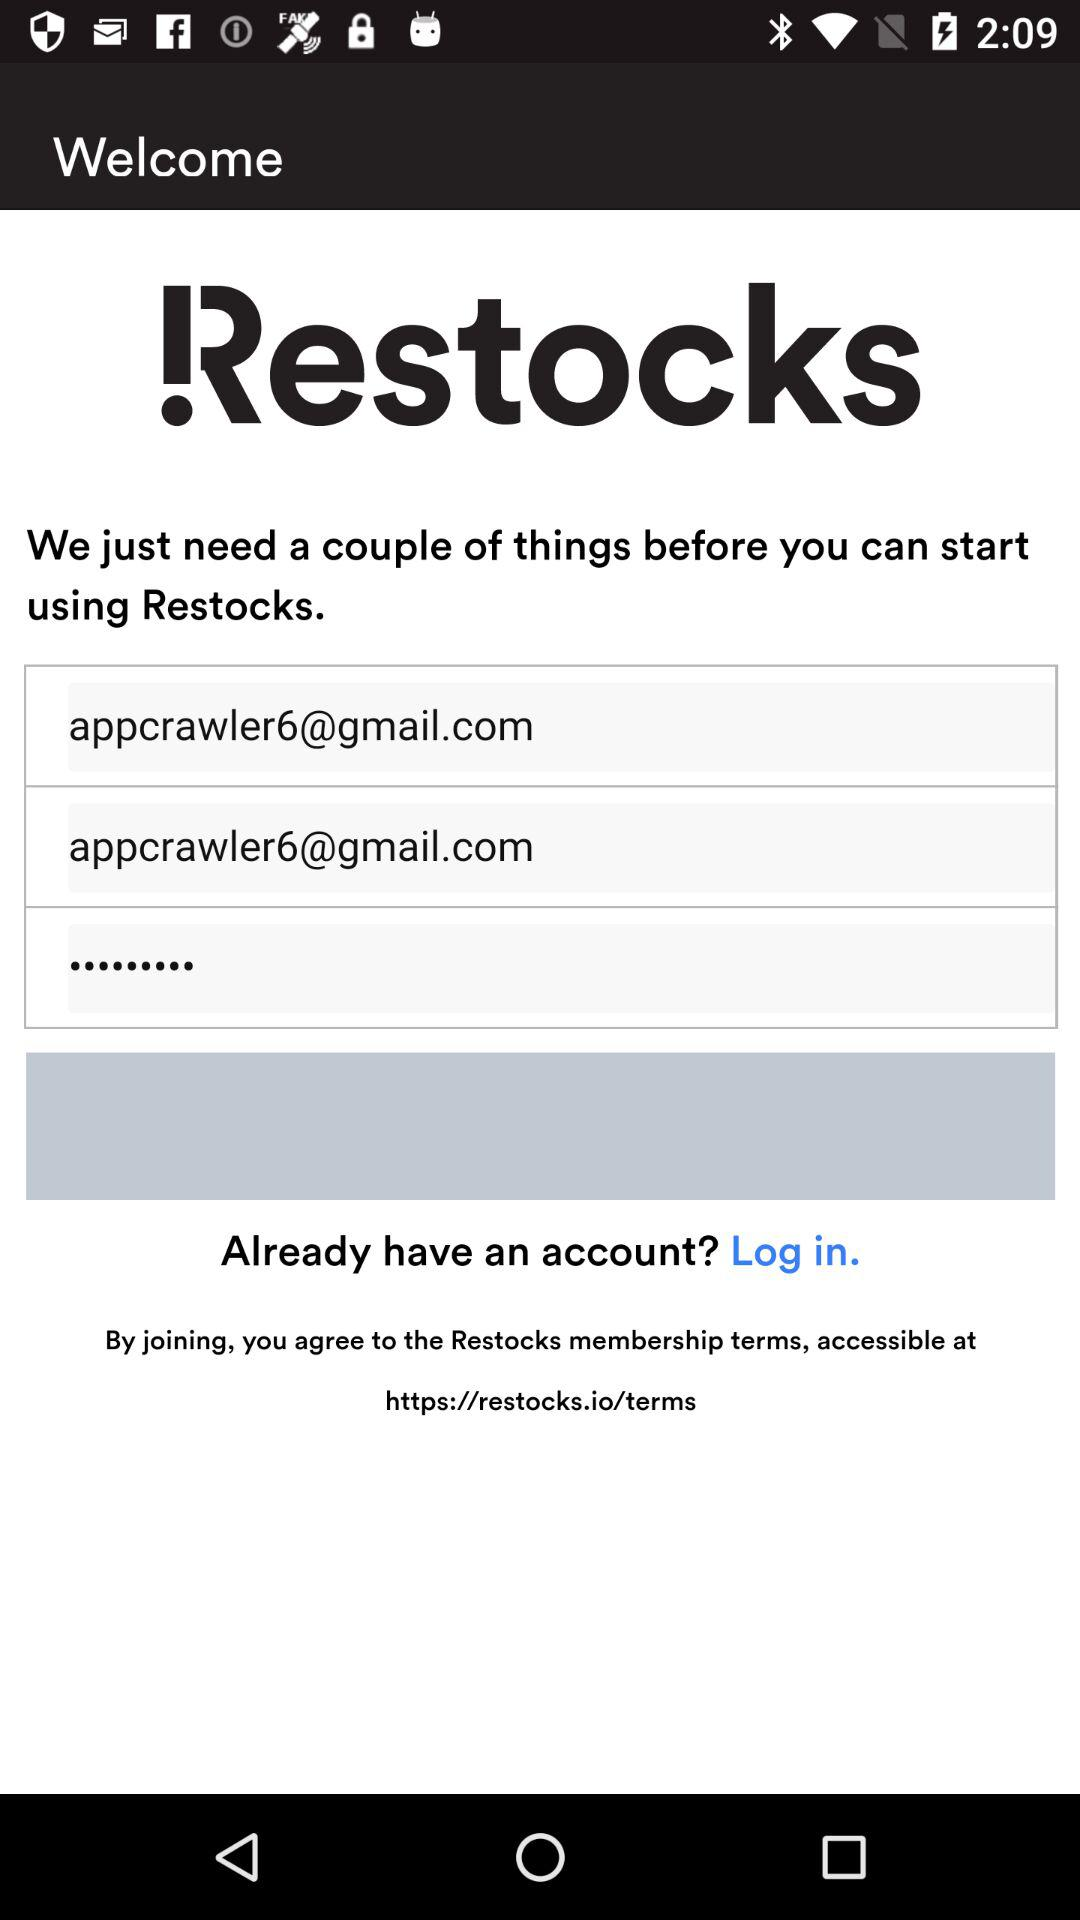What is the email address? The email address is appcrawler6@gmail.com. 